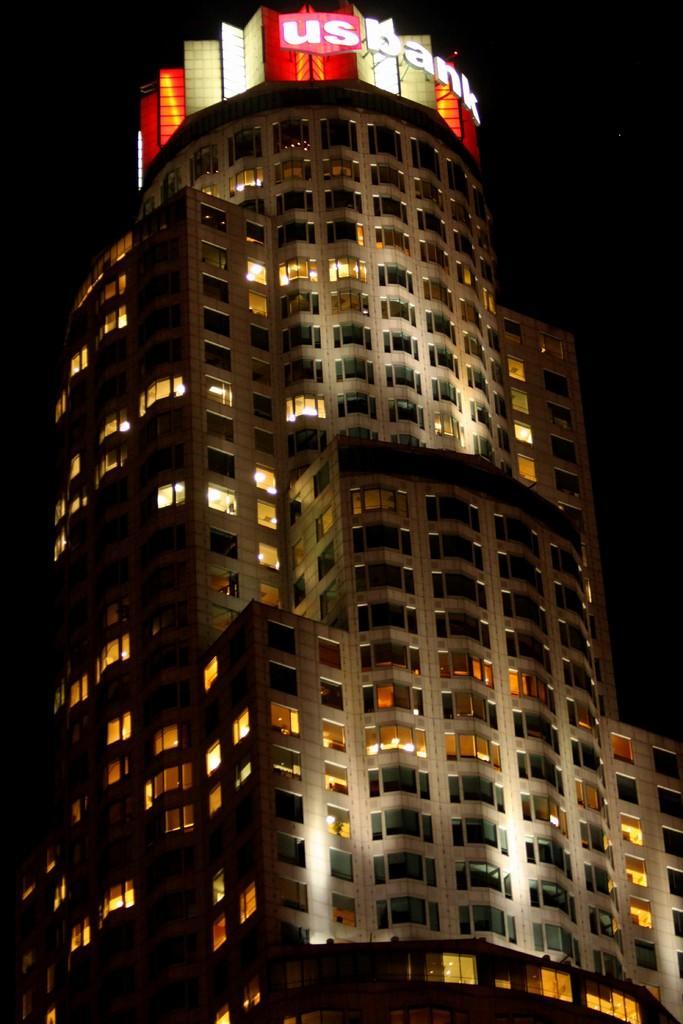Can you describe this image briefly? Here we can see a building and a board. There is a dark background. 